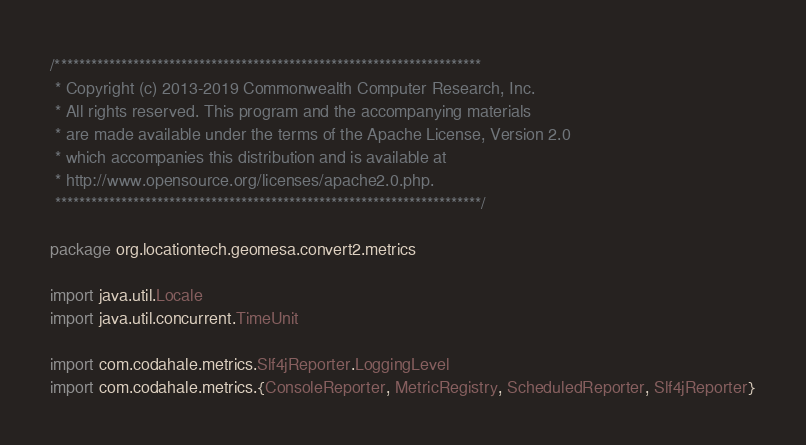Convert code to text. <code><loc_0><loc_0><loc_500><loc_500><_Scala_>/***********************************************************************
 * Copyright (c) 2013-2019 Commonwealth Computer Research, Inc.
 * All rights reserved. This program and the accompanying materials
 * are made available under the terms of the Apache License, Version 2.0
 * which accompanies this distribution and is available at
 * http://www.opensource.org/licenses/apache2.0.php.
 ***********************************************************************/

package org.locationtech.geomesa.convert2.metrics

import java.util.Locale
import java.util.concurrent.TimeUnit

import com.codahale.metrics.Slf4jReporter.LoggingLevel
import com.codahale.metrics.{ConsoleReporter, MetricRegistry, ScheduledReporter, Slf4jReporter}</code> 